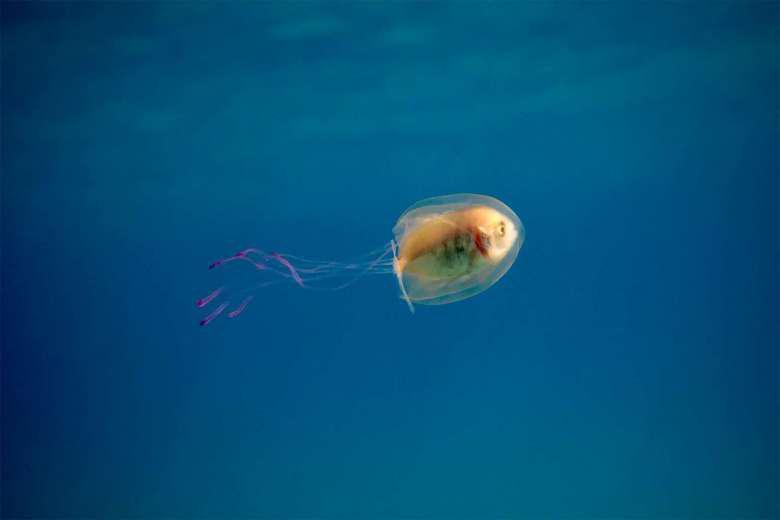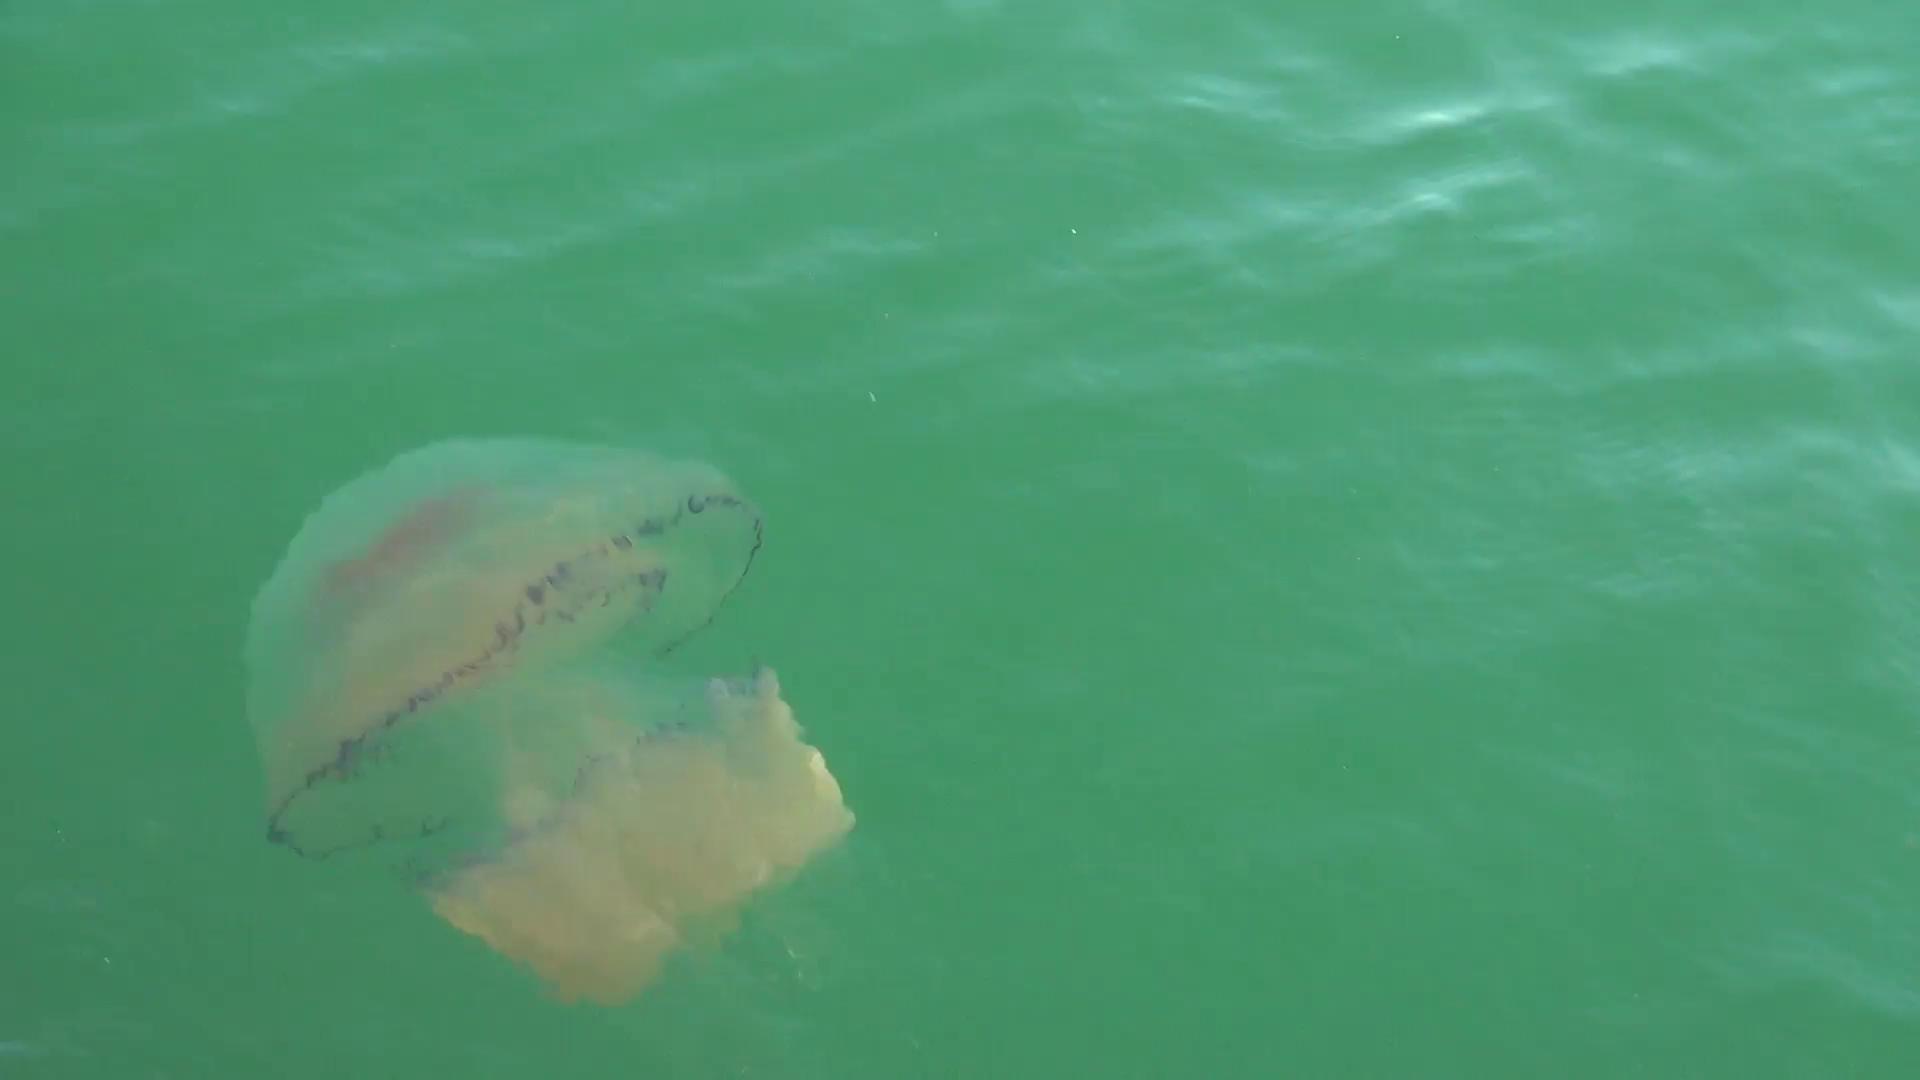The first image is the image on the left, the second image is the image on the right. Evaluate the accuracy of this statement regarding the images: "The left image includes at least one orange jellyfish with long tentacles, and the right image features a fish visible inside a translucent jellyfish.". Is it true? Answer yes or no. No. 